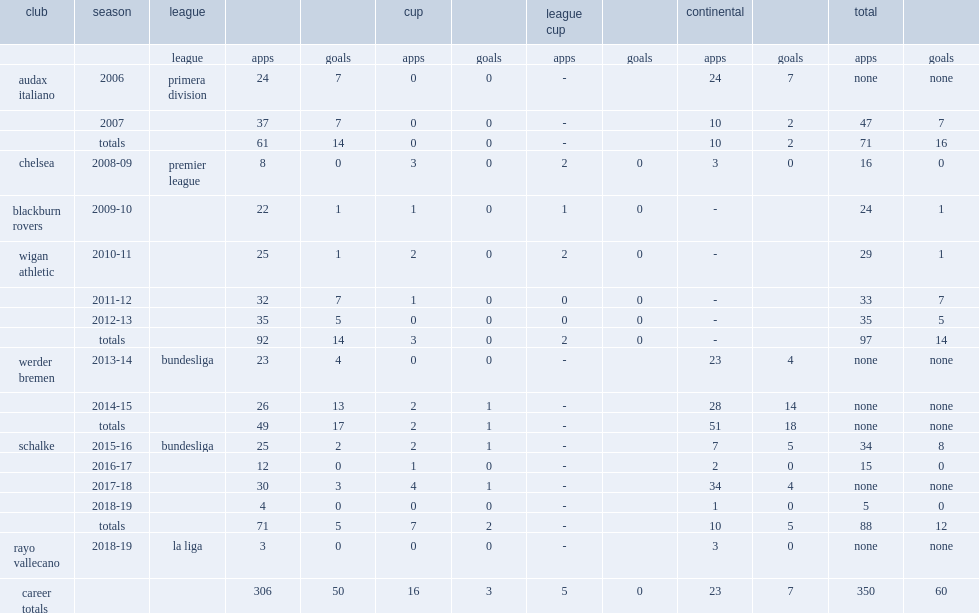How many appearances did franco di santo make during chelsea's 2008-09 premier league season? Premier league. 